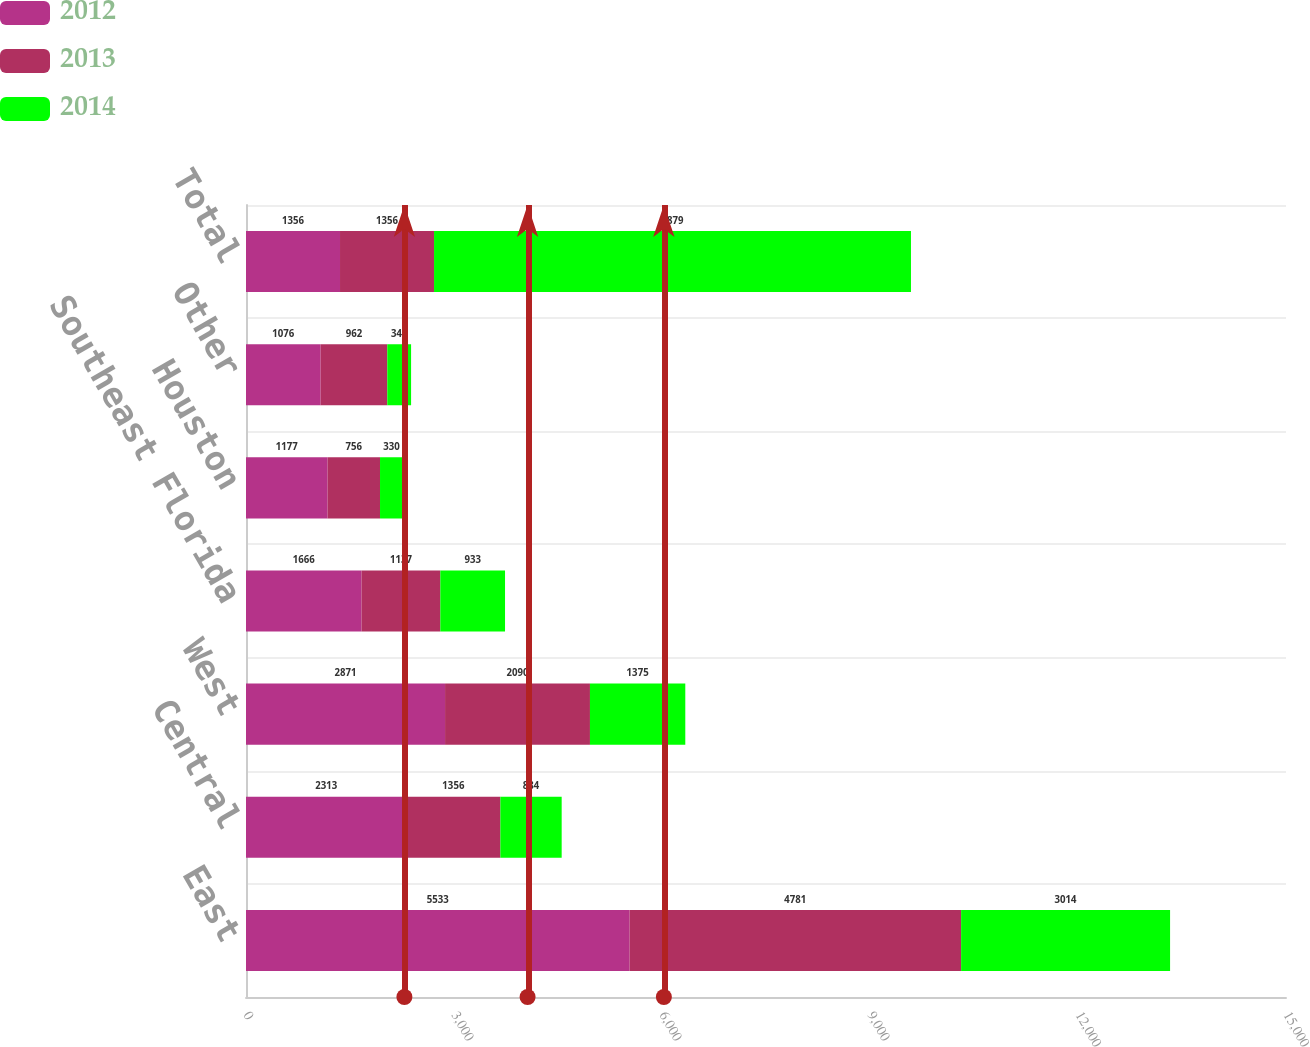Convert chart to OTSL. <chart><loc_0><loc_0><loc_500><loc_500><stacked_bar_chart><ecel><fcel>East<fcel>Central<fcel>West<fcel>Southeast Florida<fcel>Houston<fcel>Other<fcel>Total<nl><fcel>2012<fcel>5533<fcel>2313<fcel>2871<fcel>1666<fcel>1177<fcel>1076<fcel>1356<nl><fcel>2013<fcel>4781<fcel>1356<fcel>2090<fcel>1137<fcel>756<fcel>962<fcel>1356<nl><fcel>2014<fcel>3014<fcel>884<fcel>1375<fcel>933<fcel>330<fcel>343<fcel>6879<nl></chart> 